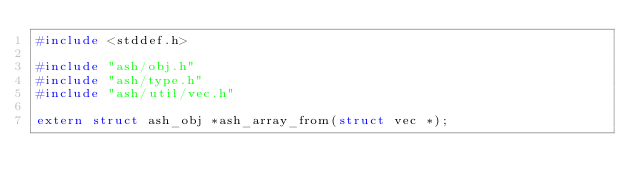Convert code to text. <code><loc_0><loc_0><loc_500><loc_500><_C_>#include <stddef.h>

#include "ash/obj.h"
#include "ash/type.h"
#include "ash/util/vec.h"

extern struct ash_obj *ash_array_from(struct vec *);</code> 